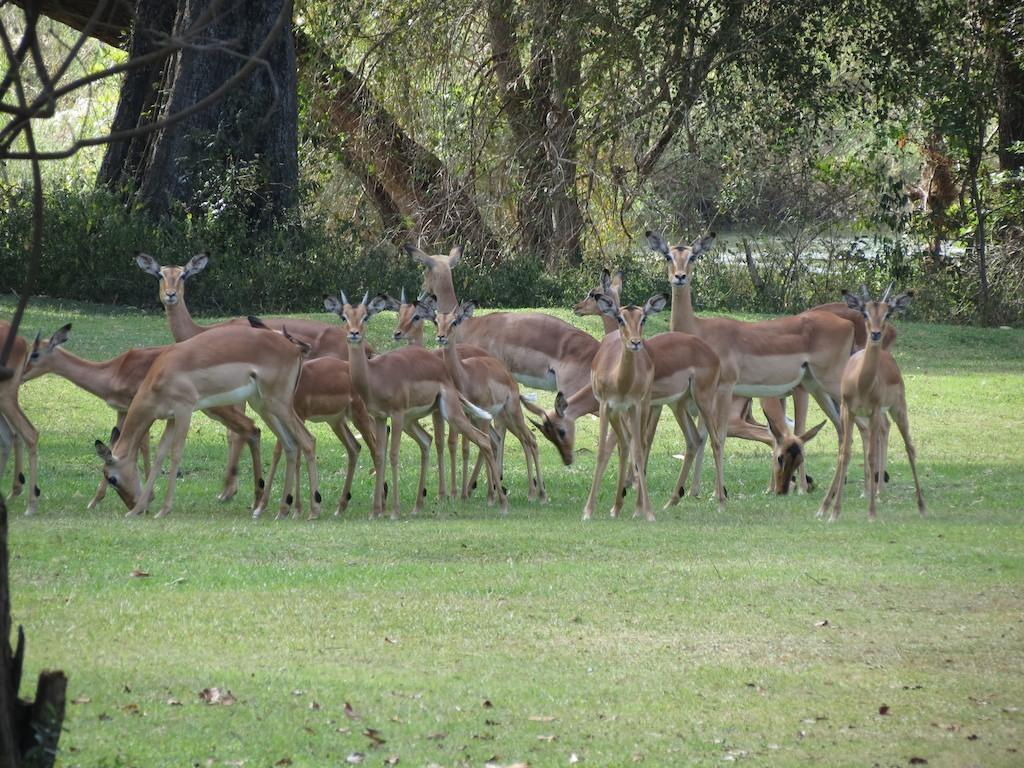What type of vegetation can be seen in the image? There are many trees, plants, bushes, and grass in the image. What is present on the ground in the image? There are leaves and animals on the ground in the image. Can you see any fog in the image? There is no fog present in the image. What type of paper can be seen in the image? There is no paper present in the image. 